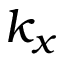<formula> <loc_0><loc_0><loc_500><loc_500>k _ { x }</formula> 